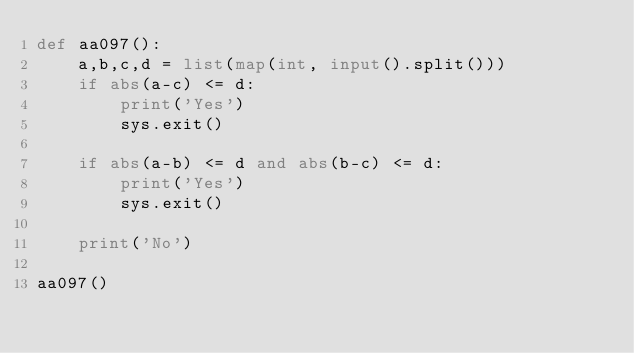<code> <loc_0><loc_0><loc_500><loc_500><_Python_>def aa097():
    a,b,c,d = list(map(int, input().split()))
    if abs(a-c) <= d:
        print('Yes')
        sys.exit()

    if abs(a-b) <= d and abs(b-c) <= d:
        print('Yes')
        sys.exit()

    print('No')

aa097()
</code> 